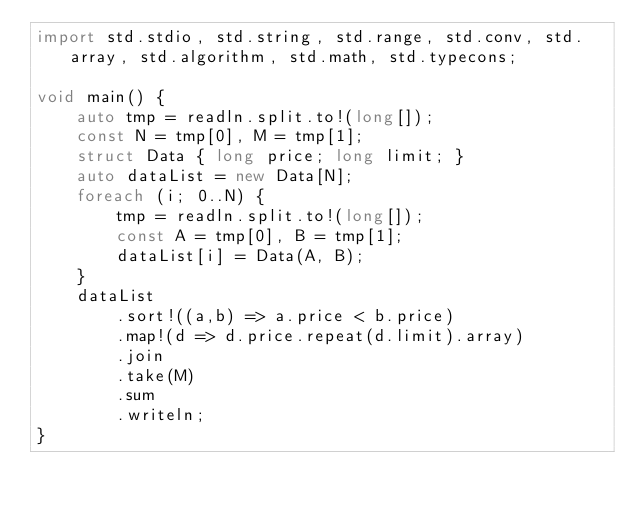<code> <loc_0><loc_0><loc_500><loc_500><_D_>import std.stdio, std.string, std.range, std.conv, std.array, std.algorithm, std.math, std.typecons;

void main() {
    auto tmp = readln.split.to!(long[]);
    const N = tmp[0], M = tmp[1];
    struct Data { long price; long limit; }
    auto dataList = new Data[N];
    foreach (i; 0..N) {
        tmp = readln.split.to!(long[]);
        const A = tmp[0], B = tmp[1];
        dataList[i] = Data(A, B);
    }
    dataList
        .sort!((a,b) => a.price < b.price)
        .map!(d => d.price.repeat(d.limit).array)
        .join
        .take(M)
        .sum
        .writeln;
}

</code> 